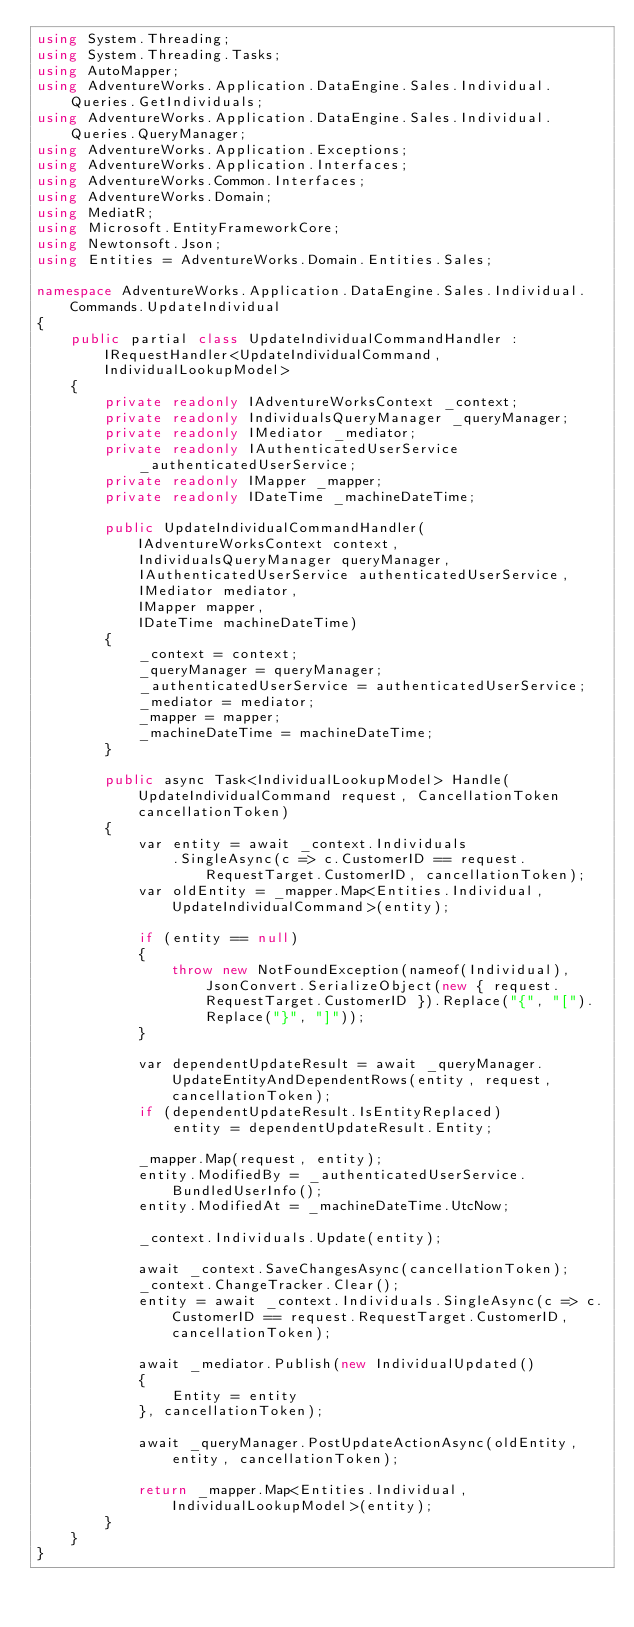Convert code to text. <code><loc_0><loc_0><loc_500><loc_500><_C#_>using System.Threading;
using System.Threading.Tasks;
using AutoMapper;
using AdventureWorks.Application.DataEngine.Sales.Individual.Queries.GetIndividuals;
using AdventureWorks.Application.DataEngine.Sales.Individual.Queries.QueryManager;
using AdventureWorks.Application.Exceptions;
using AdventureWorks.Application.Interfaces;
using AdventureWorks.Common.Interfaces;
using AdventureWorks.Domain;
using MediatR;
using Microsoft.EntityFrameworkCore;
using Newtonsoft.Json;
using Entities = AdventureWorks.Domain.Entities.Sales;

namespace AdventureWorks.Application.DataEngine.Sales.Individual.Commands.UpdateIndividual
{
    public partial class UpdateIndividualCommandHandler : IRequestHandler<UpdateIndividualCommand, IndividualLookupModel>
    {
        private readonly IAdventureWorksContext _context;
        private readonly IndividualsQueryManager _queryManager;
        private readonly IMediator _mediator;
        private readonly IAuthenticatedUserService _authenticatedUserService;
        private readonly IMapper _mapper;
        private readonly IDateTime _machineDateTime;

        public UpdateIndividualCommandHandler(IAdventureWorksContext context,
            IndividualsQueryManager queryManager,
            IAuthenticatedUserService authenticatedUserService,
            IMediator mediator,
            IMapper mapper,
            IDateTime machineDateTime)
        {
            _context = context;
            _queryManager = queryManager;
            _authenticatedUserService = authenticatedUserService;
            _mediator = mediator;
            _mapper = mapper;
            _machineDateTime = machineDateTime;
        }

        public async Task<IndividualLookupModel> Handle(UpdateIndividualCommand request, CancellationToken cancellationToken)
        {
            var entity = await _context.Individuals
                .SingleAsync(c => c.CustomerID == request.RequestTarget.CustomerID, cancellationToken);
            var oldEntity = _mapper.Map<Entities.Individual, UpdateIndividualCommand>(entity);

            if (entity == null)
            {
                throw new NotFoundException(nameof(Individual), JsonConvert.SerializeObject(new { request.RequestTarget.CustomerID }).Replace("{", "[").Replace("}", "]"));
            }

            var dependentUpdateResult = await _queryManager.UpdateEntityAndDependentRows(entity, request, cancellationToken);
            if (dependentUpdateResult.IsEntityReplaced)
                entity = dependentUpdateResult.Entity;

            _mapper.Map(request, entity);
            entity.ModifiedBy = _authenticatedUserService.BundledUserInfo();
            entity.ModifiedAt = _machineDateTime.UtcNow;

            _context.Individuals.Update(entity);

            await _context.SaveChangesAsync(cancellationToken);
            _context.ChangeTracker.Clear();
            entity = await _context.Individuals.SingleAsync(c => c.CustomerID == request.RequestTarget.CustomerID, cancellationToken);

            await _mediator.Publish(new IndividualUpdated()
            {
                Entity = entity
            }, cancellationToken);

            await _queryManager.PostUpdateActionAsync(oldEntity, entity, cancellationToken);

            return _mapper.Map<Entities.Individual, IndividualLookupModel>(entity);
        }
    }
}
</code> 